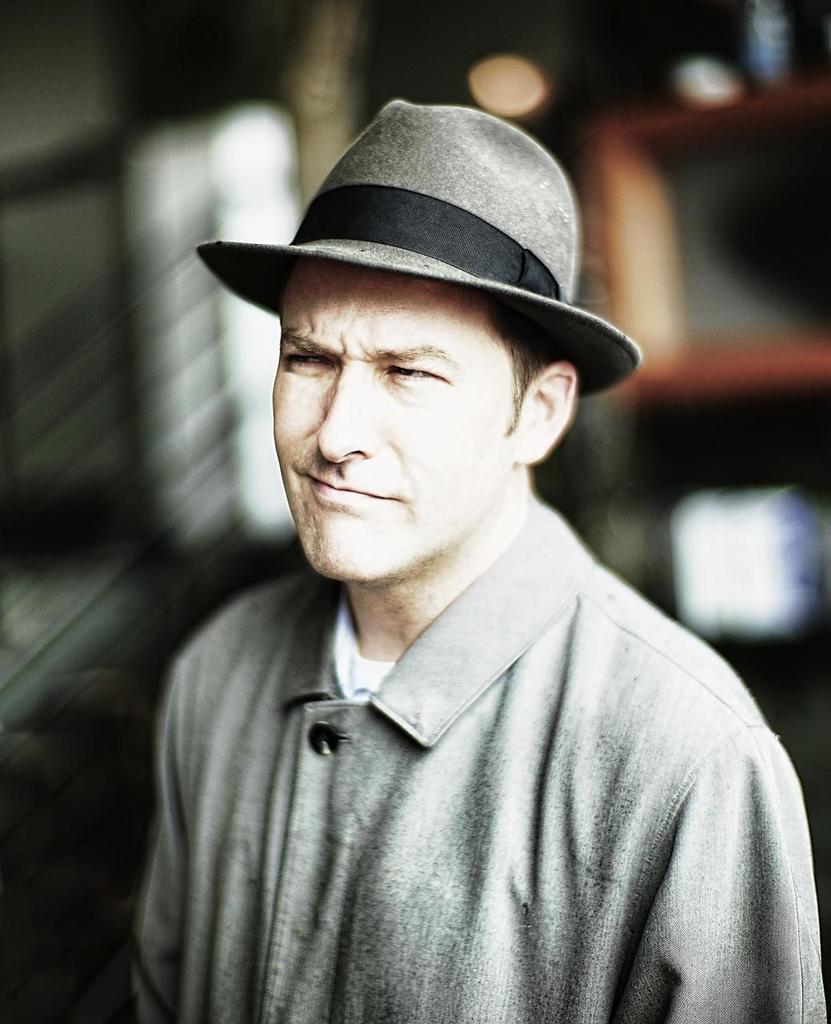What is the main subject of the image? There is a person in the image. What is the person wearing on their head? The person is wearing a hat. Can you describe the background of the image? The background of the image is blurry. What type of square can be seen in the image? There is no square present in the image. What joke is the person telling in the image? There is no indication of a joke being told in the image. 